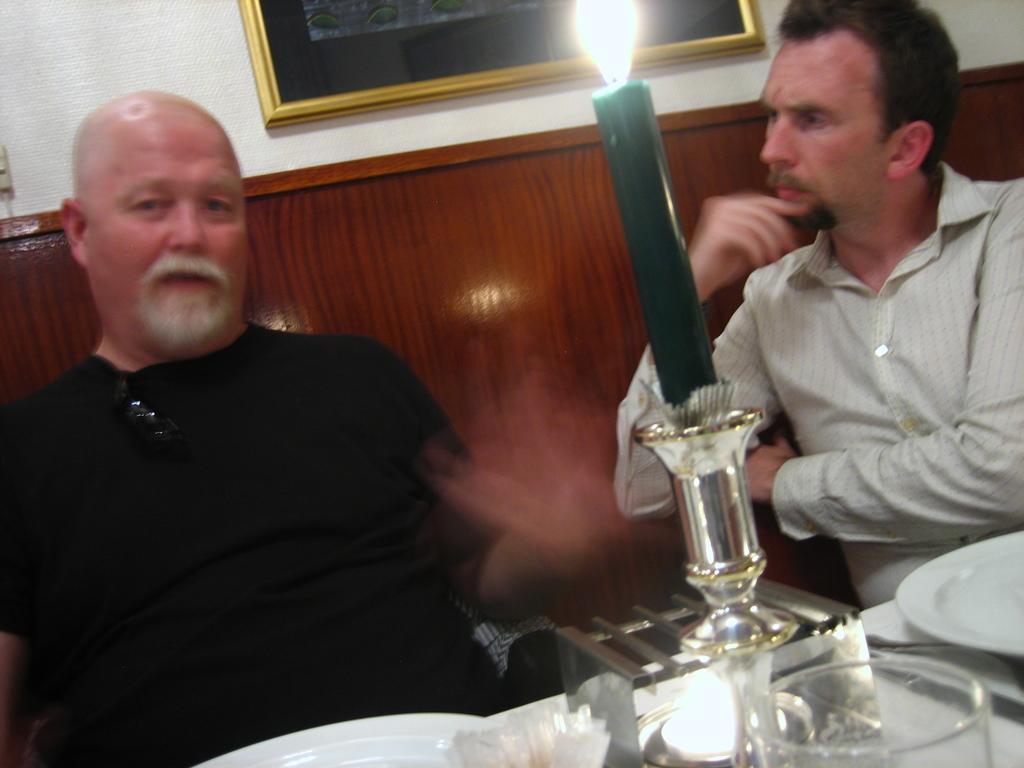How would you summarize this image in a sentence or two? In this image I can see two men where one is wearing white colour shirt and one is wearing black dress. I can also see a glass, a plate, a green colour candle and on this wall I can see a frame. 